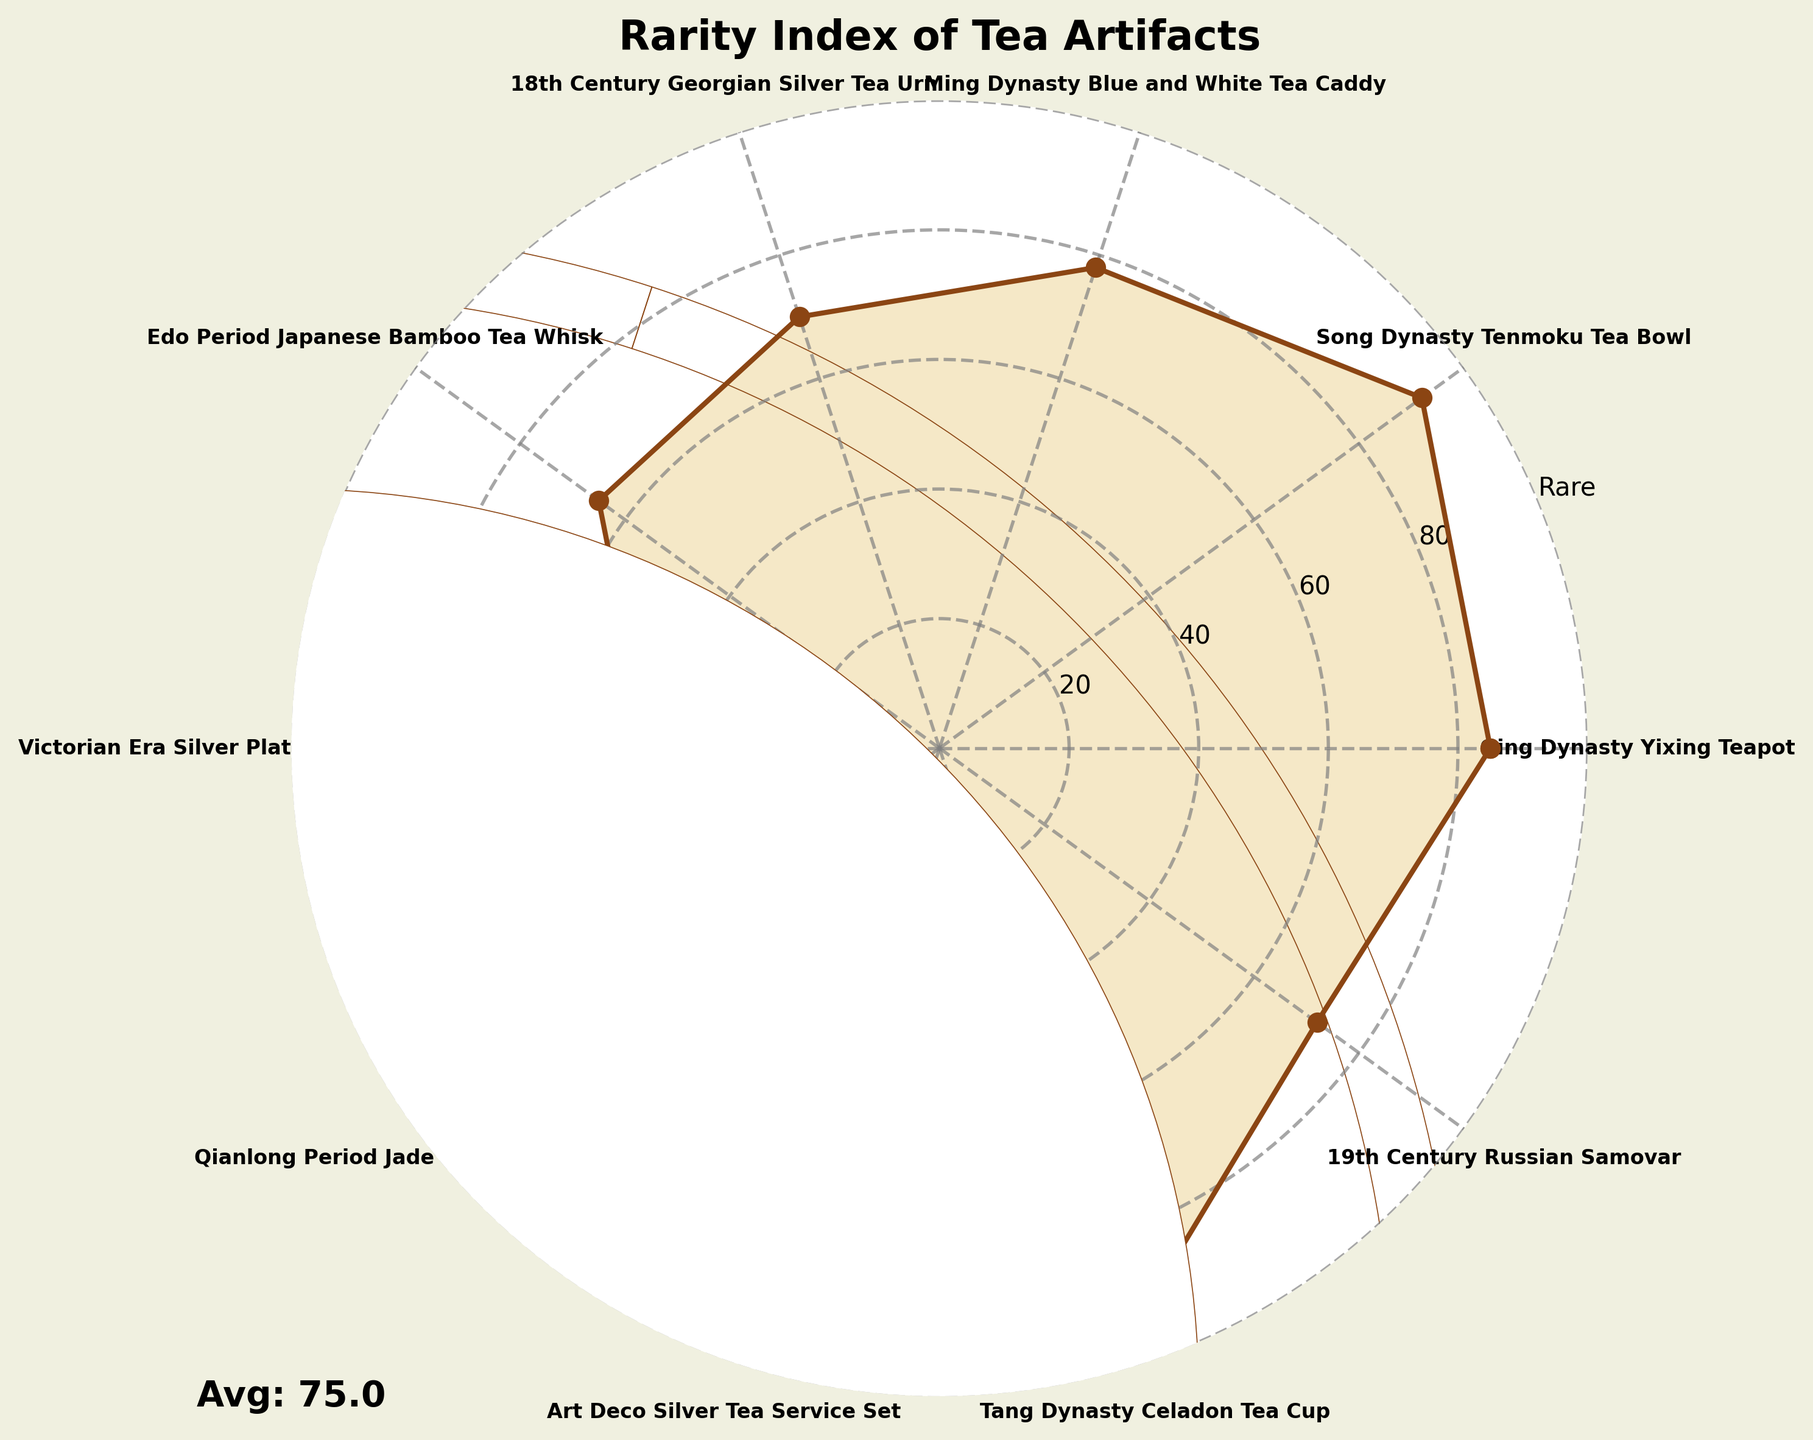Which tea artifact is considered the rarest according to the figure? The Song Dynasty Tenmoku Tea Bowl has the highest rarity score of 92, indicating it is the rarest.
Answer: Song Dynasty Tenmoku Tea Bowl What is the rarity score of the 18th Century Georgian Silver Tea Urn? According to the figure, the 18th Century Georgian Silver Tea Urn has a rarity score of 70.
Answer: 70 How many tea artifacts have a rarity score above 80? The Qing Dynasty Yixing Teapot (85), Song Dynasty Tenmoku Tea Bowl (92), Qianlong Period Jade Tea Scoop (88), and Tang Dynasty Celadon Tea Cup (95) all have rarity scores above 80. Hence, there are four artifacts with scores above 80.
Answer: 4 Which tea artifact is the least rare according to the figure? The Victorian Era Silver Plated Tea Strainer has the lowest rarity score of 45, making it the least rare.
Answer: Victorian Era Silver Plated Tea Strainer What is the average rarity score of all the tea artifacts? Adding up all the rarity scores (85 + 92 + 78 + 70 + 65 + 45 + 88 + 60 + 95 + 72) gives 750. Dividing by the number of artifacts (10) results in an average score of 75.
Answer: 75 What is the difference in rarity scores between the Tang Dynasty Celadon Tea Cup and the Victorian Era Silver Plated Tea Strainer? The Tang Dynasty Celadon Tea Cup has a score of 95, and the Victorian Era Silver Plated Tea Strainer has a score of 45. Therefore, the difference is 95 - 45 = 50.
Answer: 50 Which artifact's rarity score is closest to the average rarity score of all artifacts? The average rarity score is 75. The score of 78 for the Ming Dynasty Blue and White Tea Caddy is the closest to this average.
Answer: Ming Dynasty Blue and White Tea Caddy How many tea artifacts have a rarity score less than the average? The artifacts with scores less than the average of 75 are the 18th Century Georgian Silver Tea Urn (70), Edo Period Japanese Bamboo Tea Whisk (65), Victorian Era Silver Plated Tea Strainer (45), Art Deco Silver Tea Service Set (60), and 19th Century Russian Samovar (72). Hence, there are five artifacts with scores below the average.
Answer: 5 What is the title of the figure? The title of the figure is "Rarity Index of Tea Artifacts," as displayed at the top.
Answer: Rarity Index of Tea Artifacts 